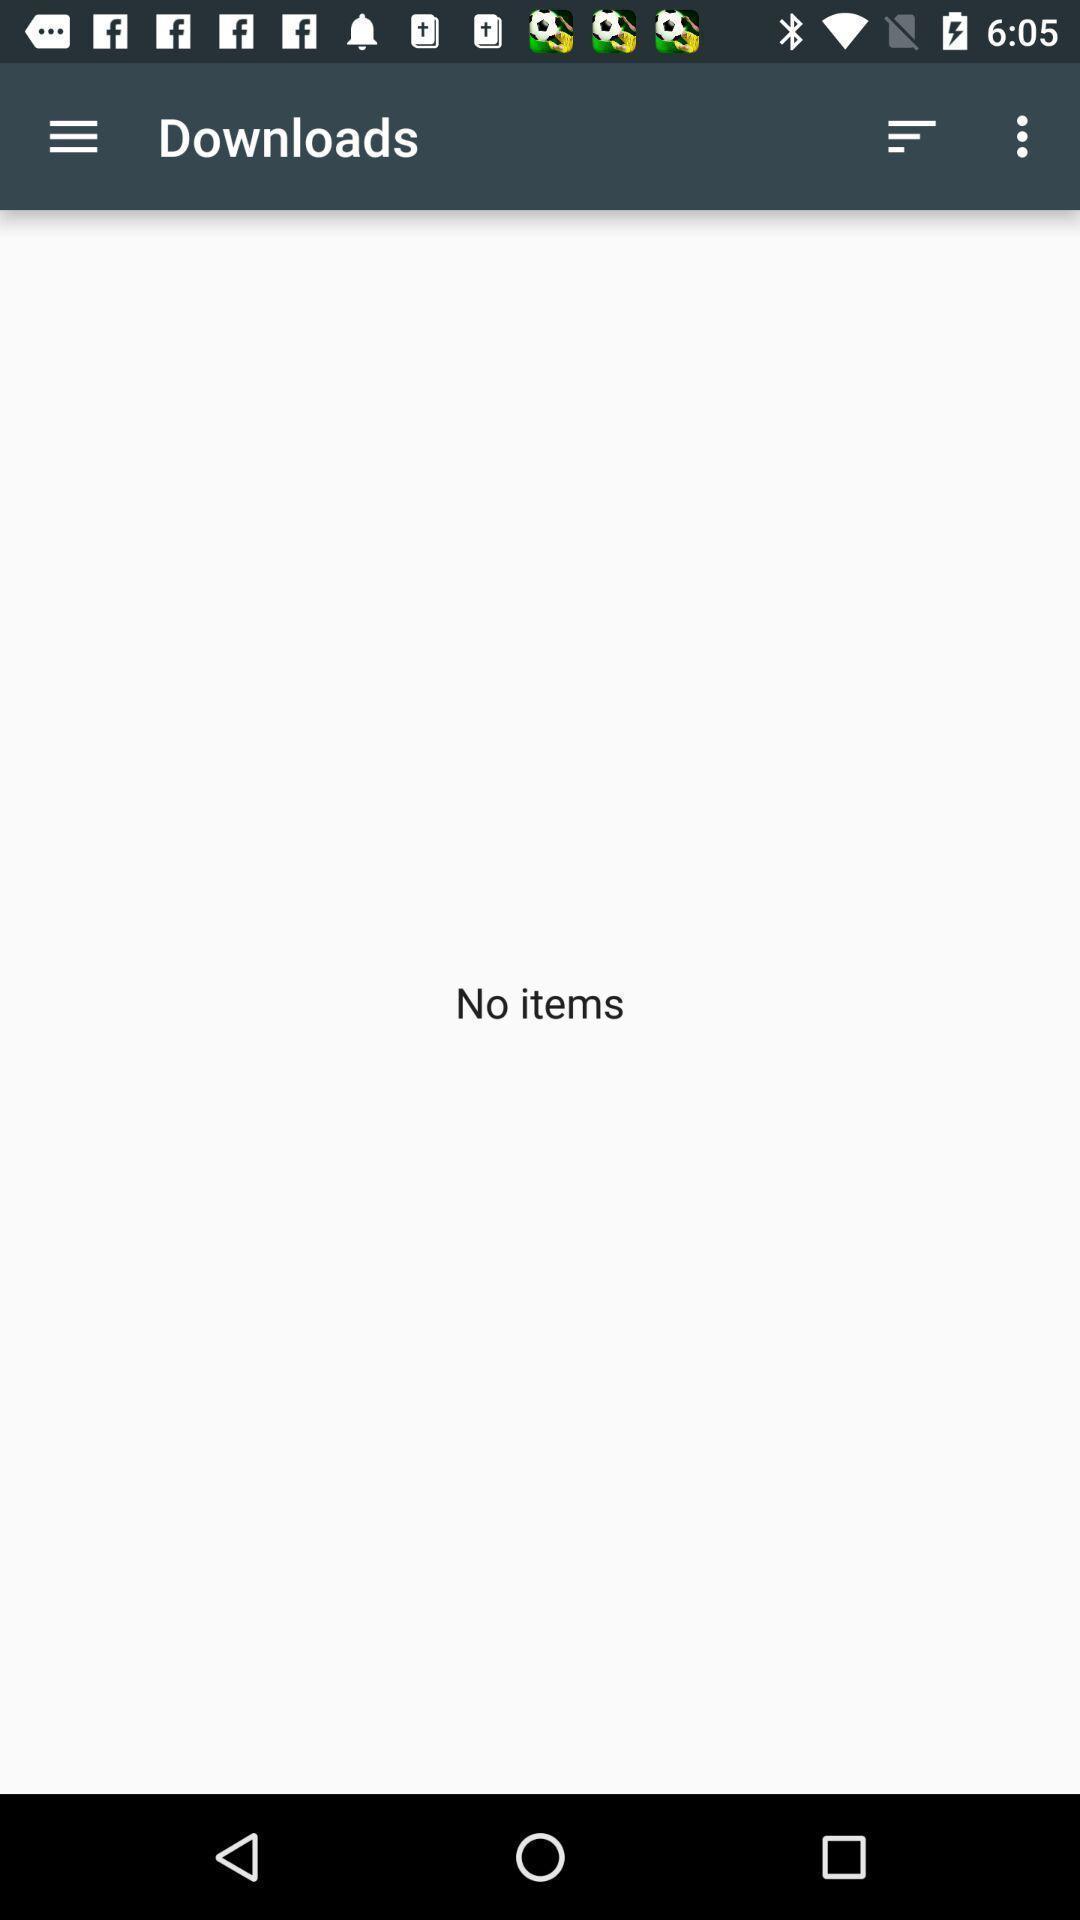Summarize the information in this screenshot. Screen showing no items in downloads. 